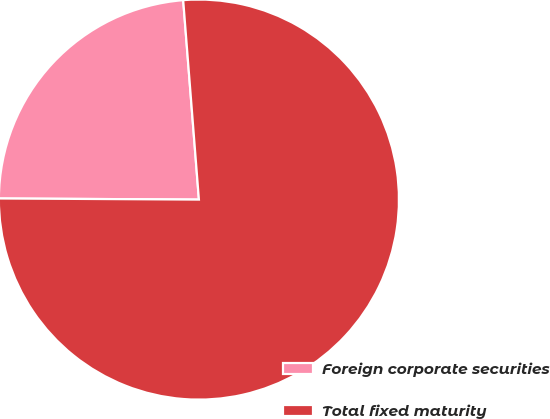Convert chart to OTSL. <chart><loc_0><loc_0><loc_500><loc_500><pie_chart><fcel>Foreign corporate securities<fcel>Total fixed maturity<nl><fcel>23.66%<fcel>76.34%<nl></chart> 